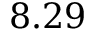Convert formula to latex. <formula><loc_0><loc_0><loc_500><loc_500>8 . 2 9</formula> 